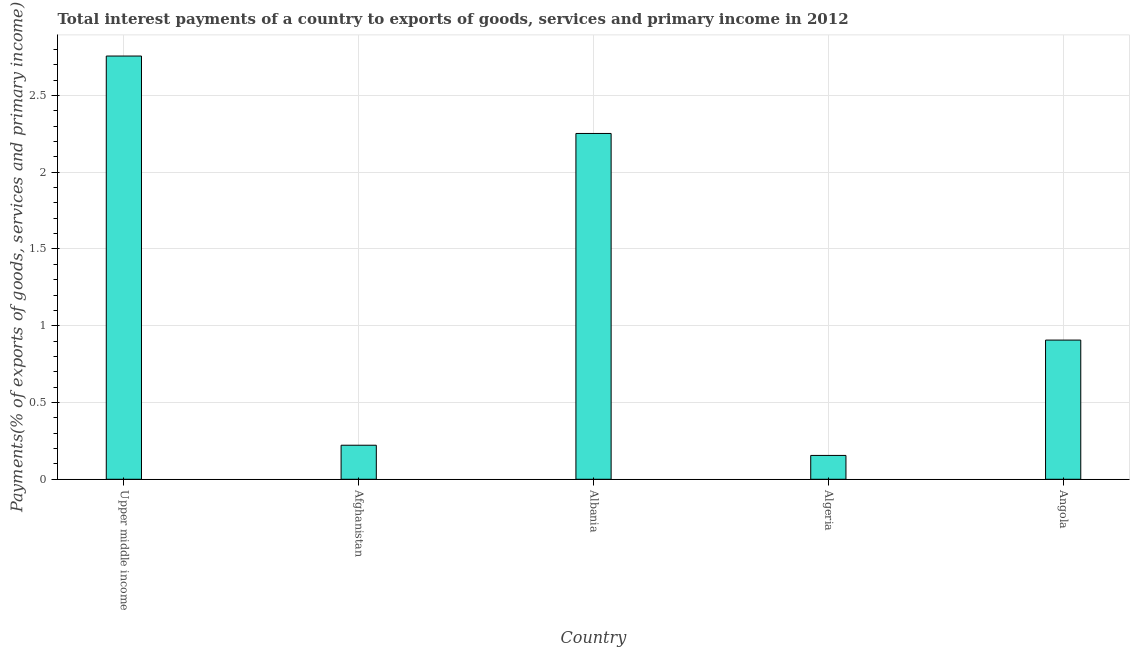Does the graph contain any zero values?
Make the answer very short. No. Does the graph contain grids?
Keep it short and to the point. Yes. What is the title of the graph?
Your response must be concise. Total interest payments of a country to exports of goods, services and primary income in 2012. What is the label or title of the X-axis?
Your response must be concise. Country. What is the label or title of the Y-axis?
Keep it short and to the point. Payments(% of exports of goods, services and primary income). What is the total interest payments on external debt in Angola?
Offer a terse response. 0.91. Across all countries, what is the maximum total interest payments on external debt?
Offer a terse response. 2.76. Across all countries, what is the minimum total interest payments on external debt?
Make the answer very short. 0.16. In which country was the total interest payments on external debt maximum?
Your response must be concise. Upper middle income. In which country was the total interest payments on external debt minimum?
Offer a very short reply. Algeria. What is the sum of the total interest payments on external debt?
Offer a very short reply. 6.29. What is the difference between the total interest payments on external debt in Albania and Upper middle income?
Offer a very short reply. -0.5. What is the average total interest payments on external debt per country?
Your answer should be compact. 1.26. What is the median total interest payments on external debt?
Your answer should be very brief. 0.91. In how many countries, is the total interest payments on external debt greater than 0.5 %?
Keep it short and to the point. 3. Is the total interest payments on external debt in Albania less than that in Angola?
Your answer should be compact. No. Is the difference between the total interest payments on external debt in Albania and Algeria greater than the difference between any two countries?
Offer a terse response. No. What is the difference between the highest and the second highest total interest payments on external debt?
Your response must be concise. 0.5. Is the sum of the total interest payments on external debt in Algeria and Upper middle income greater than the maximum total interest payments on external debt across all countries?
Make the answer very short. Yes. What is the difference between two consecutive major ticks on the Y-axis?
Make the answer very short. 0.5. What is the Payments(% of exports of goods, services and primary income) of Upper middle income?
Your answer should be compact. 2.76. What is the Payments(% of exports of goods, services and primary income) of Afghanistan?
Offer a terse response. 0.22. What is the Payments(% of exports of goods, services and primary income) of Albania?
Your answer should be compact. 2.25. What is the Payments(% of exports of goods, services and primary income) of Algeria?
Your answer should be compact. 0.16. What is the Payments(% of exports of goods, services and primary income) of Angola?
Your response must be concise. 0.91. What is the difference between the Payments(% of exports of goods, services and primary income) in Upper middle income and Afghanistan?
Ensure brevity in your answer.  2.53. What is the difference between the Payments(% of exports of goods, services and primary income) in Upper middle income and Albania?
Your answer should be compact. 0.5. What is the difference between the Payments(% of exports of goods, services and primary income) in Upper middle income and Algeria?
Ensure brevity in your answer.  2.6. What is the difference between the Payments(% of exports of goods, services and primary income) in Upper middle income and Angola?
Ensure brevity in your answer.  1.85. What is the difference between the Payments(% of exports of goods, services and primary income) in Afghanistan and Albania?
Provide a short and direct response. -2.03. What is the difference between the Payments(% of exports of goods, services and primary income) in Afghanistan and Algeria?
Keep it short and to the point. 0.07. What is the difference between the Payments(% of exports of goods, services and primary income) in Afghanistan and Angola?
Your response must be concise. -0.68. What is the difference between the Payments(% of exports of goods, services and primary income) in Albania and Algeria?
Keep it short and to the point. 2.1. What is the difference between the Payments(% of exports of goods, services and primary income) in Albania and Angola?
Give a very brief answer. 1.35. What is the difference between the Payments(% of exports of goods, services and primary income) in Algeria and Angola?
Keep it short and to the point. -0.75. What is the ratio of the Payments(% of exports of goods, services and primary income) in Upper middle income to that in Afghanistan?
Keep it short and to the point. 12.43. What is the ratio of the Payments(% of exports of goods, services and primary income) in Upper middle income to that in Albania?
Give a very brief answer. 1.22. What is the ratio of the Payments(% of exports of goods, services and primary income) in Upper middle income to that in Algeria?
Ensure brevity in your answer.  17.75. What is the ratio of the Payments(% of exports of goods, services and primary income) in Upper middle income to that in Angola?
Keep it short and to the point. 3.04. What is the ratio of the Payments(% of exports of goods, services and primary income) in Afghanistan to that in Albania?
Your answer should be compact. 0.1. What is the ratio of the Payments(% of exports of goods, services and primary income) in Afghanistan to that in Algeria?
Keep it short and to the point. 1.43. What is the ratio of the Payments(% of exports of goods, services and primary income) in Afghanistan to that in Angola?
Ensure brevity in your answer.  0.24. What is the ratio of the Payments(% of exports of goods, services and primary income) in Albania to that in Algeria?
Ensure brevity in your answer.  14.5. What is the ratio of the Payments(% of exports of goods, services and primary income) in Albania to that in Angola?
Keep it short and to the point. 2.48. What is the ratio of the Payments(% of exports of goods, services and primary income) in Algeria to that in Angola?
Your answer should be very brief. 0.17. 